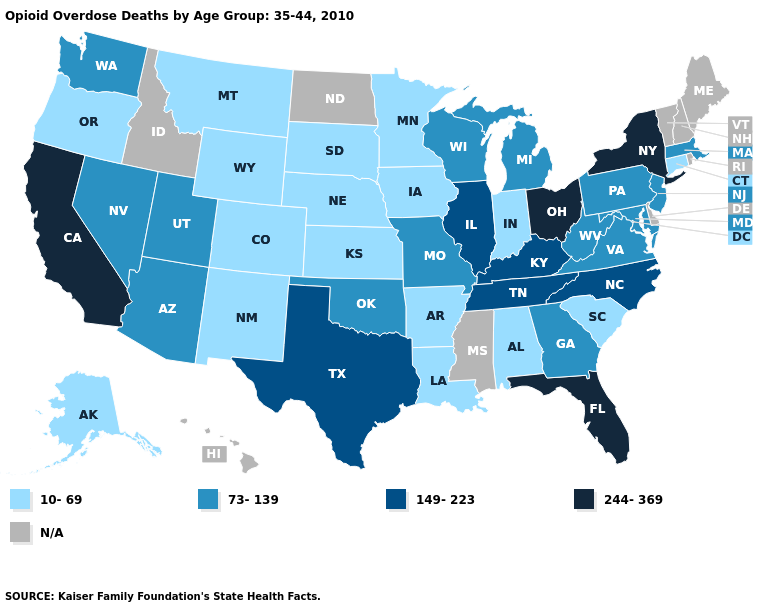Does Connecticut have the lowest value in the Northeast?
Concise answer only. Yes. What is the value of Alabama?
Write a very short answer. 10-69. What is the value of Colorado?
Answer briefly. 10-69. Does the map have missing data?
Keep it brief. Yes. What is the value of Illinois?
Write a very short answer. 149-223. How many symbols are there in the legend?
Short answer required. 5. Which states have the lowest value in the USA?
Concise answer only. Alabama, Alaska, Arkansas, Colorado, Connecticut, Indiana, Iowa, Kansas, Louisiana, Minnesota, Montana, Nebraska, New Mexico, Oregon, South Carolina, South Dakota, Wyoming. Which states have the highest value in the USA?
Answer briefly. California, Florida, New York, Ohio. Does South Dakota have the lowest value in the USA?
Write a very short answer. Yes. Among the states that border California , does Nevada have the highest value?
Concise answer only. Yes. What is the highest value in states that border Nevada?
Keep it brief. 244-369. Which states have the lowest value in the USA?
Concise answer only. Alabama, Alaska, Arkansas, Colorado, Connecticut, Indiana, Iowa, Kansas, Louisiana, Minnesota, Montana, Nebraska, New Mexico, Oregon, South Carolina, South Dakota, Wyoming. Among the states that border Washington , which have the lowest value?
Write a very short answer. Oregon. 